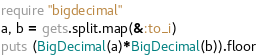<code> <loc_0><loc_0><loc_500><loc_500><_Ruby_>require "bigdecimal"
a, b = gets.split.map(&:to_i)
puts (BigDecimal(a)*BigDecimal(b)).floor</code> 